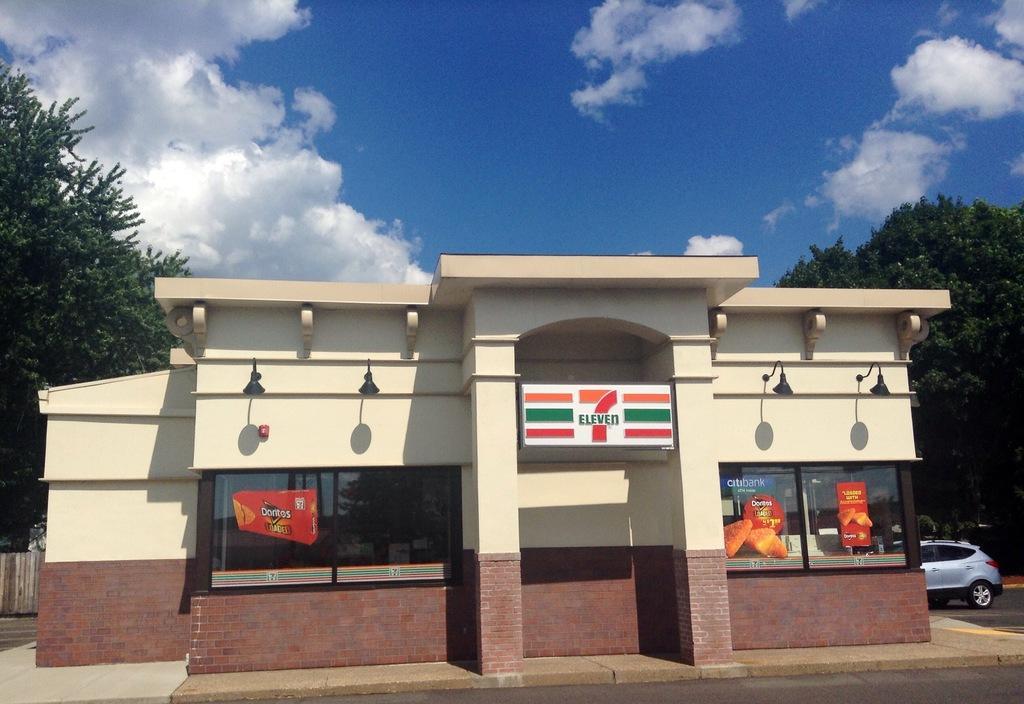Could you give a brief overview of what you see in this image? In this image there is a building and a name board, few trees, a vehicle, lights attached to the wall of the building and some clouds in the sky. 